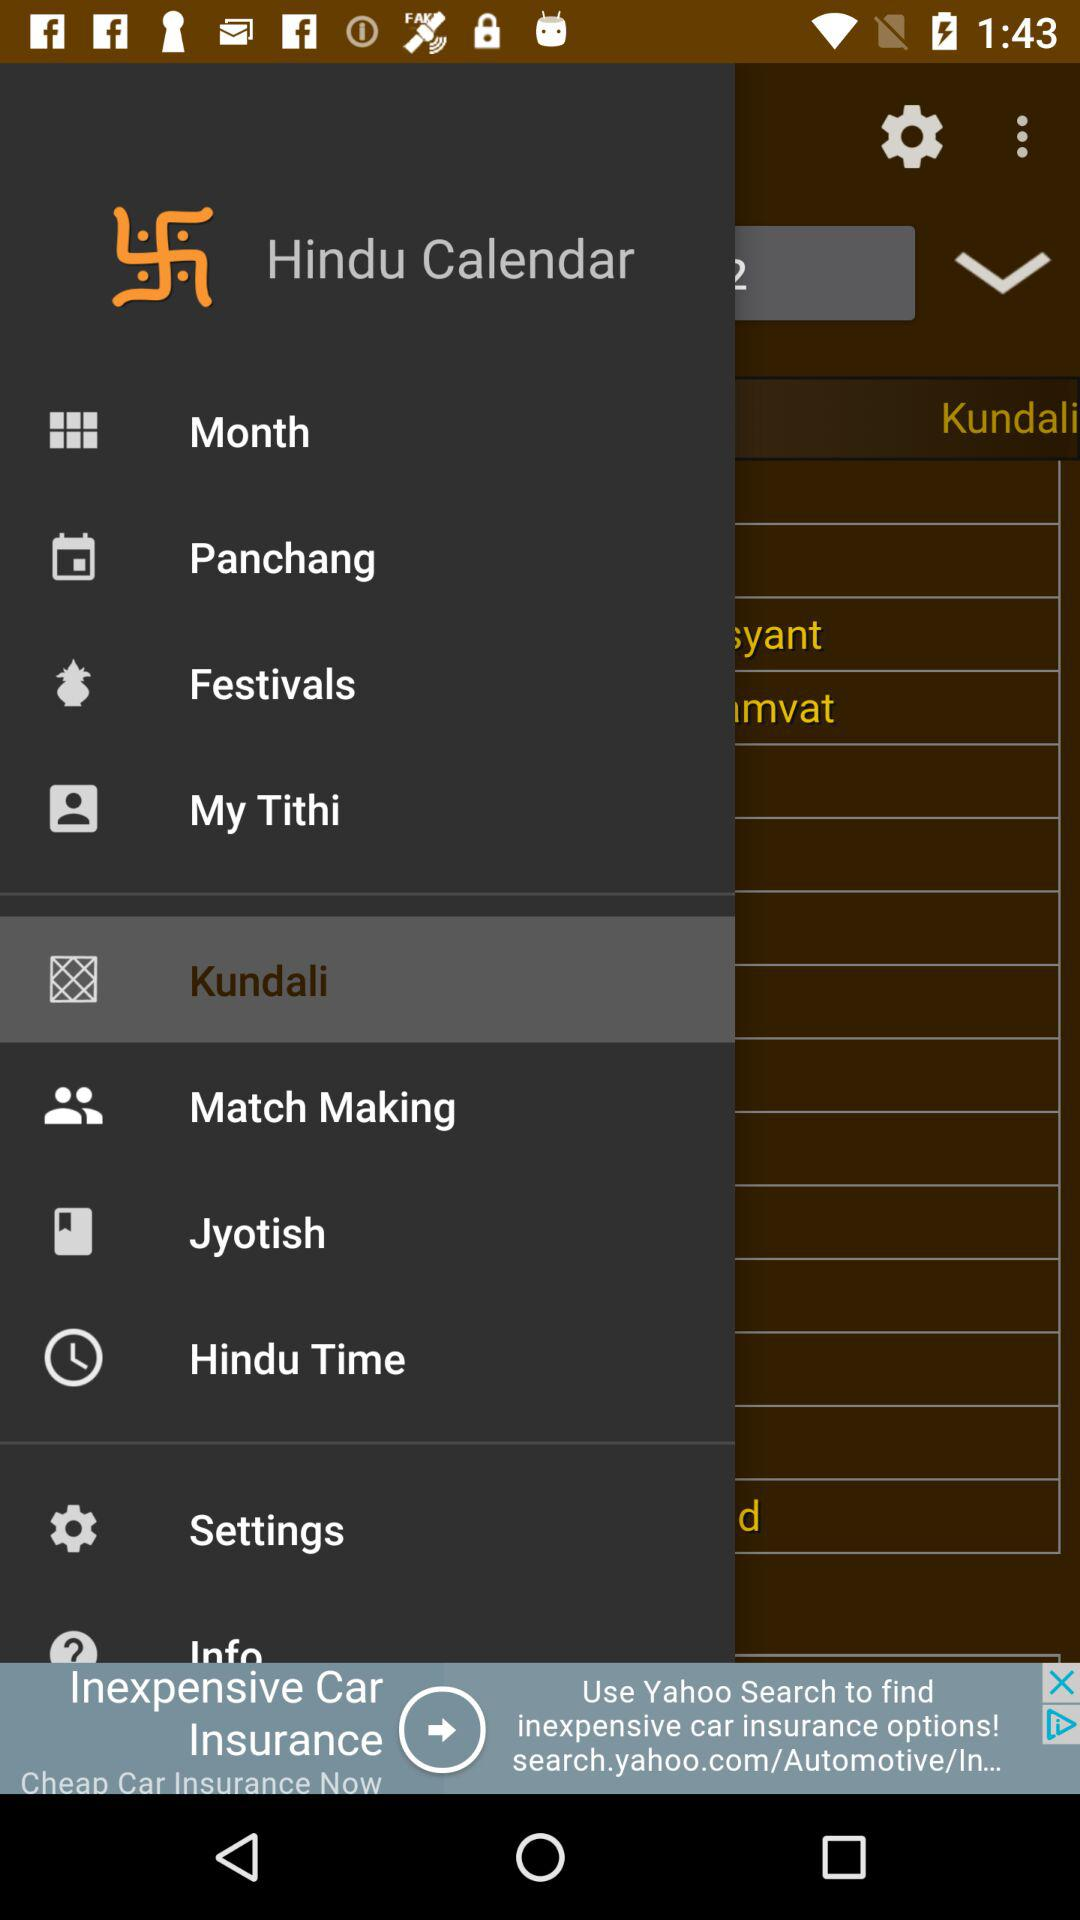Which is the selected item in the menu? The selected item is "Kundali". 